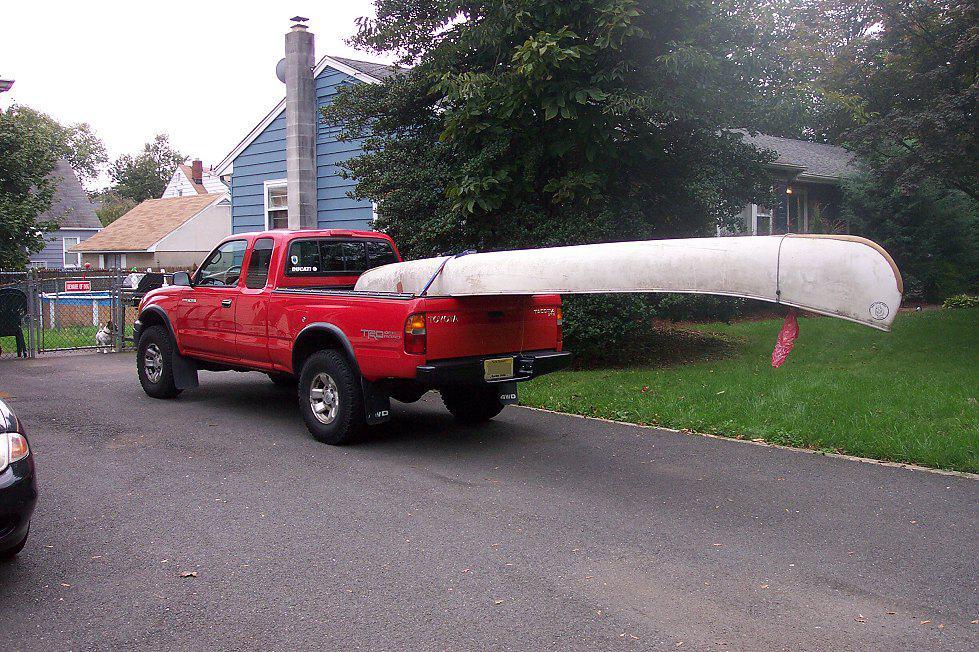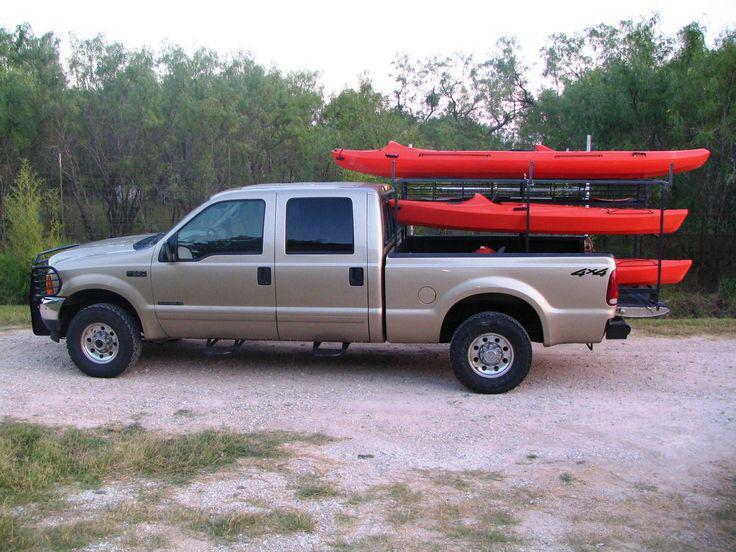The first image is the image on the left, the second image is the image on the right. Given the left and right images, does the statement "In one image, a pickup truck near a body of water has one canoe loaded on a roof rack, while a second image shows a pickup truck near a green woody area with two canoes loaded overhead." hold true? Answer yes or no. No. The first image is the image on the left, the second image is the image on the right. Evaluate the accuracy of this statement regarding the images: "The left image contains one red truck.". Is it true? Answer yes or no. Yes. 